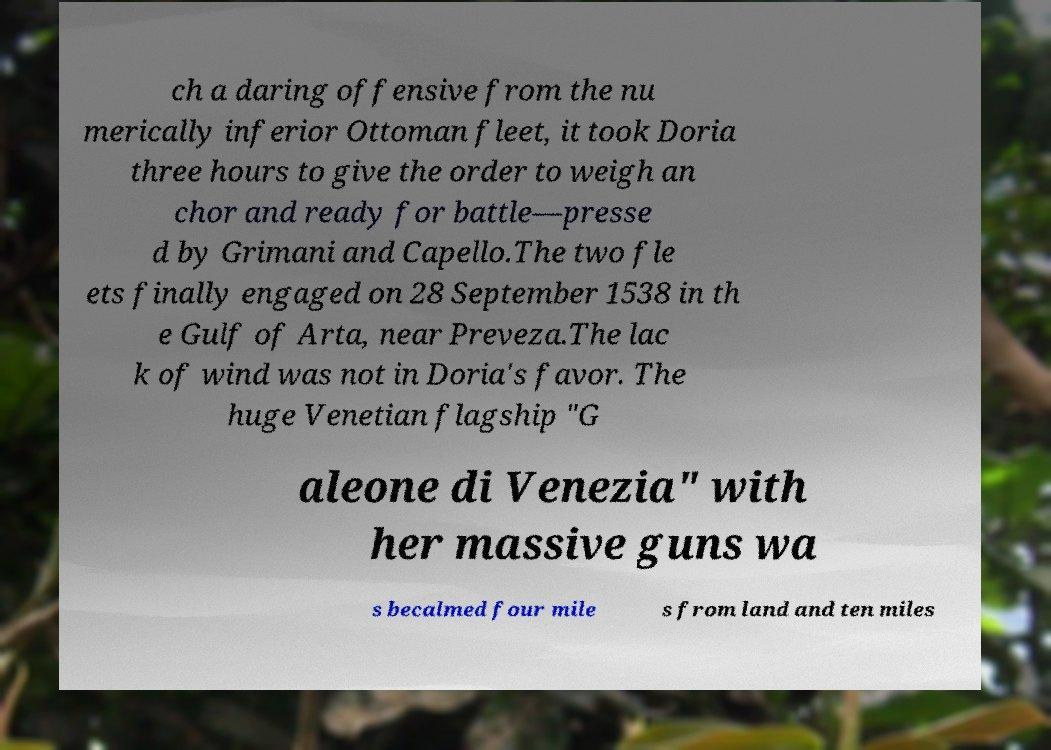Can you accurately transcribe the text from the provided image for me? ch a daring offensive from the nu merically inferior Ottoman fleet, it took Doria three hours to give the order to weigh an chor and ready for battle—presse d by Grimani and Capello.The two fle ets finally engaged on 28 September 1538 in th e Gulf of Arta, near Preveza.The lac k of wind was not in Doria's favor. The huge Venetian flagship "G aleone di Venezia" with her massive guns wa s becalmed four mile s from land and ten miles 